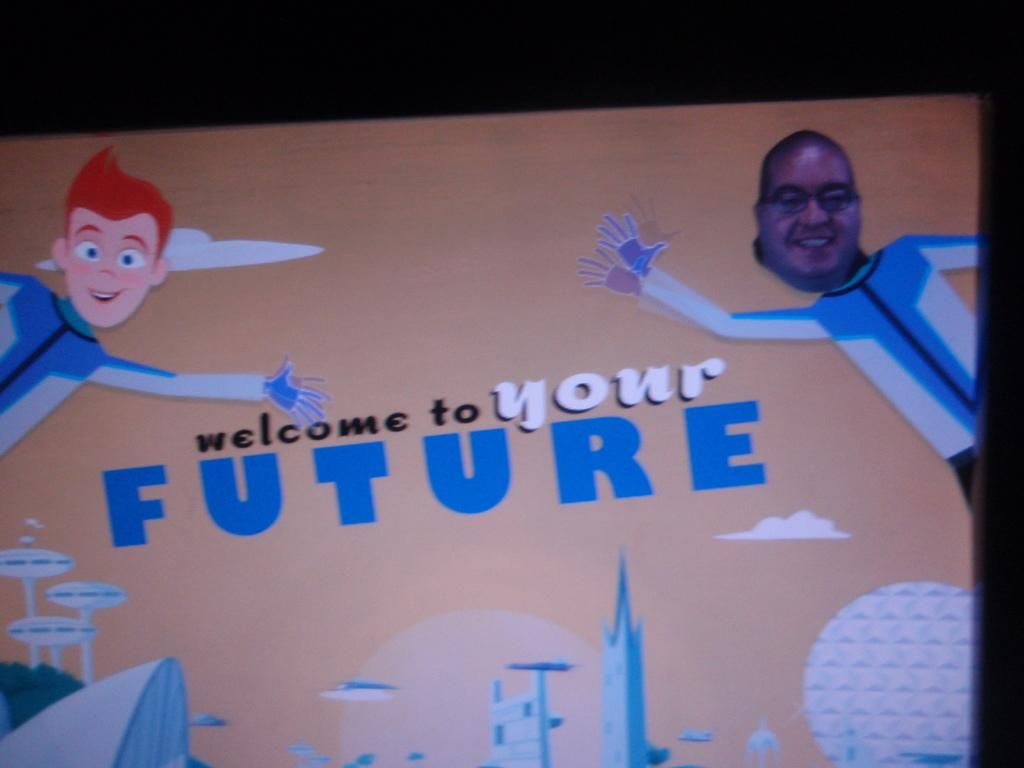What is the main object in the image? There is a board in the image. What can be seen on the board? The board has pictures and text on it. What is the color of the background in the image? The background of the image is dark. Can you tell me how many firemen are depicted on the board? There is no fireman present on the board; it only has pictures and text. What type of animal can be seen interacting with the pictures on the board? There is no animal, such as a cow or rabbit, present on the board; it only has pictures and text. 